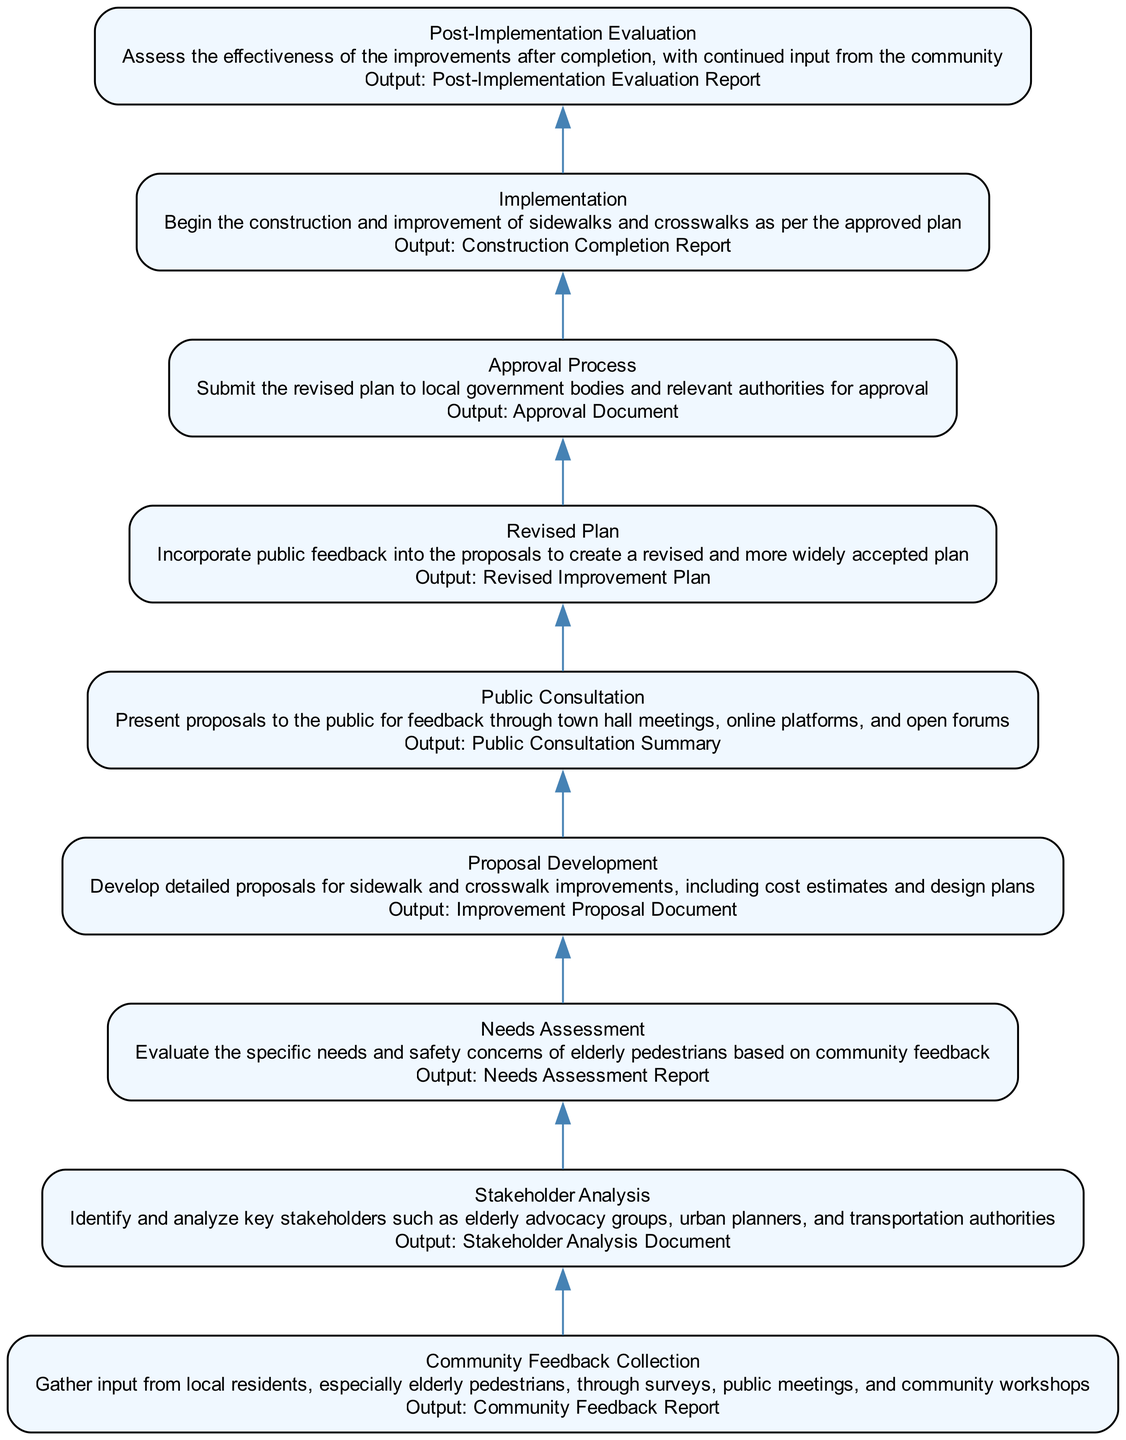What is the first step in the workflow? The first step in the workflow is "Community Feedback Collection." This can be found at the bottom of the flow chart, which is where the process begins.
Answer: Community Feedback Collection What is the output of the "Public Consultation" step? The output of the "Public Consultation" step, which is connected to the previous step, is the "Public Consultation Summary." This output is listed directly beneath the step in the flowchart.
Answer: Public Consultation Summary How many total steps are in the workflow? The total number of steps in the workflow can be counted by looking at the nodes in the diagram. There are 9 distinct steps leading from the bottom to the top.
Answer: 9 Which step immediately follows the "Needs Assessment"? The step that immediately follows "Needs Assessment" in the upward flow is "Proposal Development." This is determined by finding "Needs Assessment" and looking at the edge that connects it to the next step above.
Answer: Proposal Development What is the output of the last step in the workflow? The last step in the workflow is "Post-Implementation Evaluation," and its output is the "Post-Implementation Evaluation Report." This can be directly observed in the diagram as each step lists its corresponding output.
Answer: Post-Implementation Evaluation Report Which steps involve public feedback? The steps that involve public feedback are "Public Consultation" and "Revised Plan." This is established by examining the steps that specifically mention public input or feedback.
Answer: Public Consultation, Revised Plan What comes before the "Approval Process"? The step that comes before the "Approval Process" is "Revised Plan." This can be identified by following the upward flow from "Approval Process" to see which step directly precedes it.
Answer: Revised Plan Which steps have reports as their outputs? The steps that have reports as their outputs are "Community Feedback Collection," "Needs Assessment," "Public Consultation," "Revised Plan," and "Post-Implementation Evaluation," as each of these steps lists a specific report as its output.
Answer: Community Feedback Report, Needs Assessment Report, Public Consultation Summary, Revised Improvement Plan, Post-Implementation Evaluation Report What is the relationship between "Implementation" and "Approval Process"? "Implementation" follows the "Approval Process," indicating that the construction and improvement actions take place only after receiving the necessary approval from local government bodies. This is shown by the upward flow from "Approval Process" to "Implementation."
Answer: Implementation follows Approval Process 